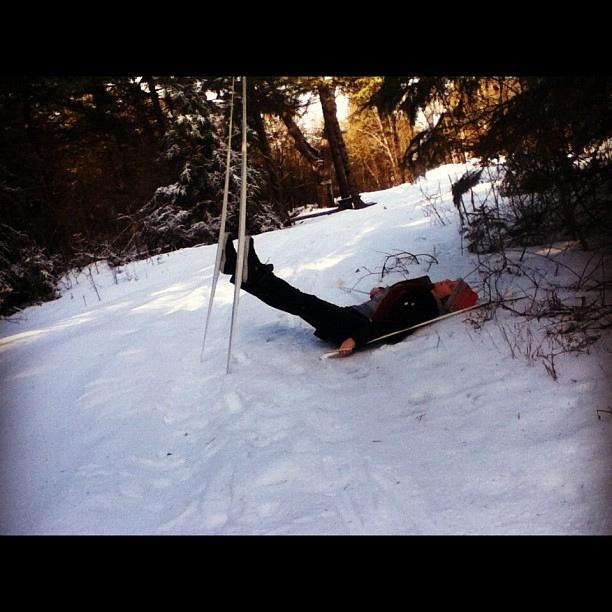How many people in the image?
Quick response, please. 1. What is on the person's feet?
Answer briefly. Skis. What is the person doing?
Be succinct. Skiing. Are his skis on the ground?
Quick response, please. No. 